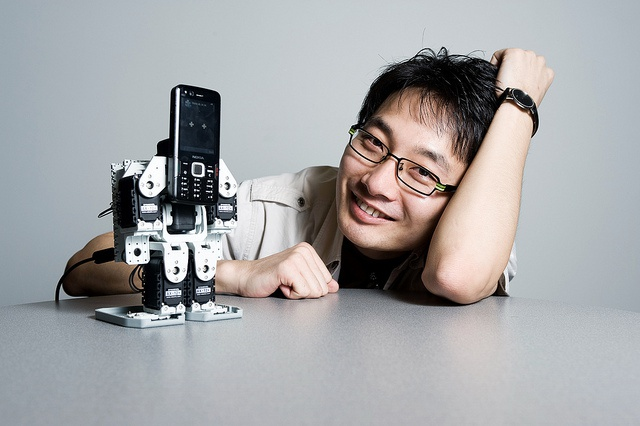Describe the objects in this image and their specific colors. I can see people in darkgray, lightgray, black, tan, and gray tones and cell phone in darkgray, black, gray, and white tones in this image. 